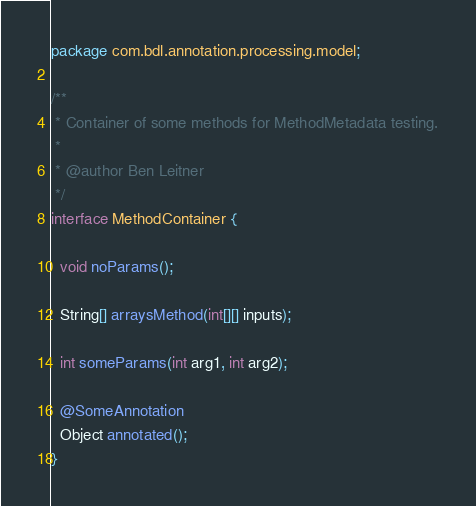Convert code to text. <code><loc_0><loc_0><loc_500><loc_500><_Java_>package com.bdl.annotation.processing.model;

/**
 * Container of some methods for MethodMetadata testing.
 *
 * @author Ben Leitner
 */
interface MethodContainer {

  void noParams();

  String[] arraysMethod(int[][] inputs);

  int someParams(int arg1, int arg2);

  @SomeAnnotation
  Object annotated();
}
</code> 